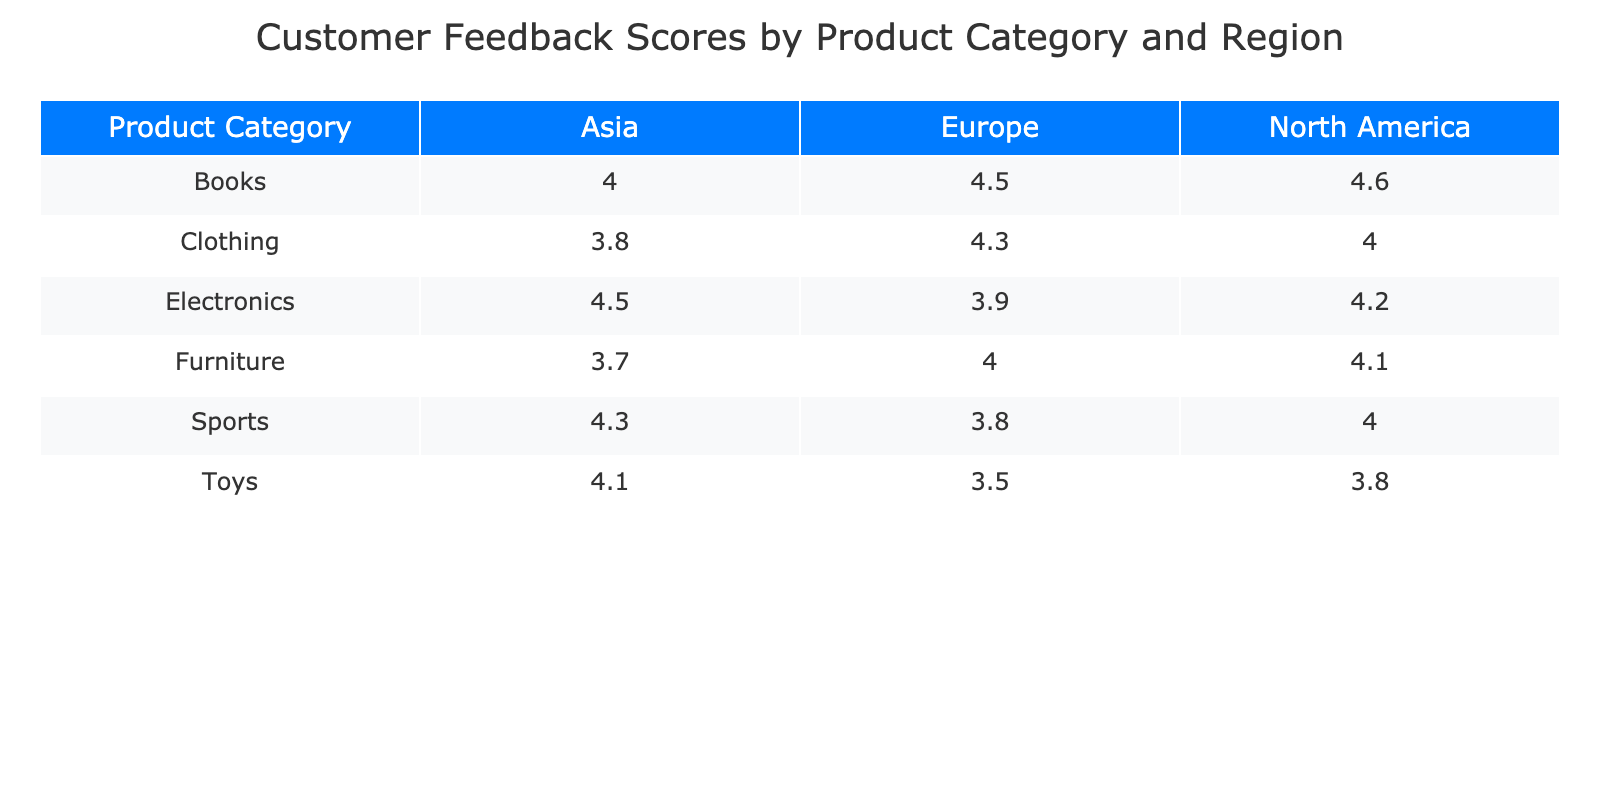What is the customer feedback score for Electronics in North America? The score for Electronics in North America is listed directly in the table as 4.2.
Answer: 4.2 What is the highest customer feedback score among all product categories in Europe? From the table, we see that the scores for Europe are: Electronics (3.9), Clothing (4.3), Furniture (4.0), Toys (3.5), Books (4.5), and Sports (3.8). The highest score is 4.5 for Books.
Answer: 4.5 Is the customer feedback score for Clothing higher in North America than in Asia? The score for Clothing in North America is 4.0, and in Asia, it is 3.8. Since 4.0 is greater than 3.8, the answer is yes.
Answer: Yes What is the average customer feedback score for all products in Asia? The scores for Asia are: Electronics (4.5), Clothing (3.8), Furniture (3.7), Toys (4.1), Books (4.0), Sports (4.3). Adding these gives 4.5 + 3.8 + 3.7 + 4.1 + 4.0 + 4.3 = 24.4. Dividing by the number of products (6) gives an average of 24.4 / 6 = 4.07.
Answer: 4.07 Which region has the lowest feedback score for Toys? The feedback scores for Toys by region are: North America (3.8), Europe (3.5), and Asia (4.1). The lowest score is 3.5 in Europe.
Answer: Europe Are there any product categories with a customer feedback score of 4.0 or less in North America? The categories with scores of 4.0 or less in North America are Toys (3.8) and Sports (4.0). Therefore, the answer is yes.
Answer: Yes What is the customer feedback score difference for Furniture between North America and Asia? The score for Furniture in North America is 4.1, and in Asia, it is 3.7. The difference is 4.1 - 3.7 = 0.4.
Answer: 0.4 